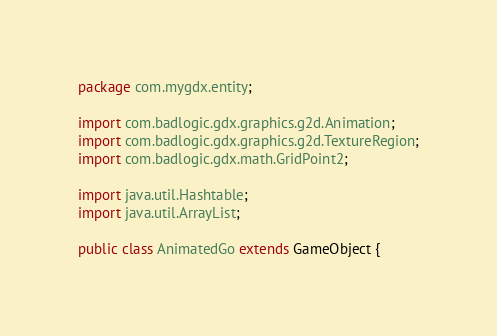Convert code to text. <code><loc_0><loc_0><loc_500><loc_500><_Java_>package com.mygdx.entity;

import com.badlogic.gdx.graphics.g2d.Animation;
import com.badlogic.gdx.graphics.g2d.TextureRegion;
import com.badlogic.gdx.math.GridPoint2;

import java.util.Hashtable;
import java.util.ArrayList;

public class AnimatedGo extends GameObject {</code> 